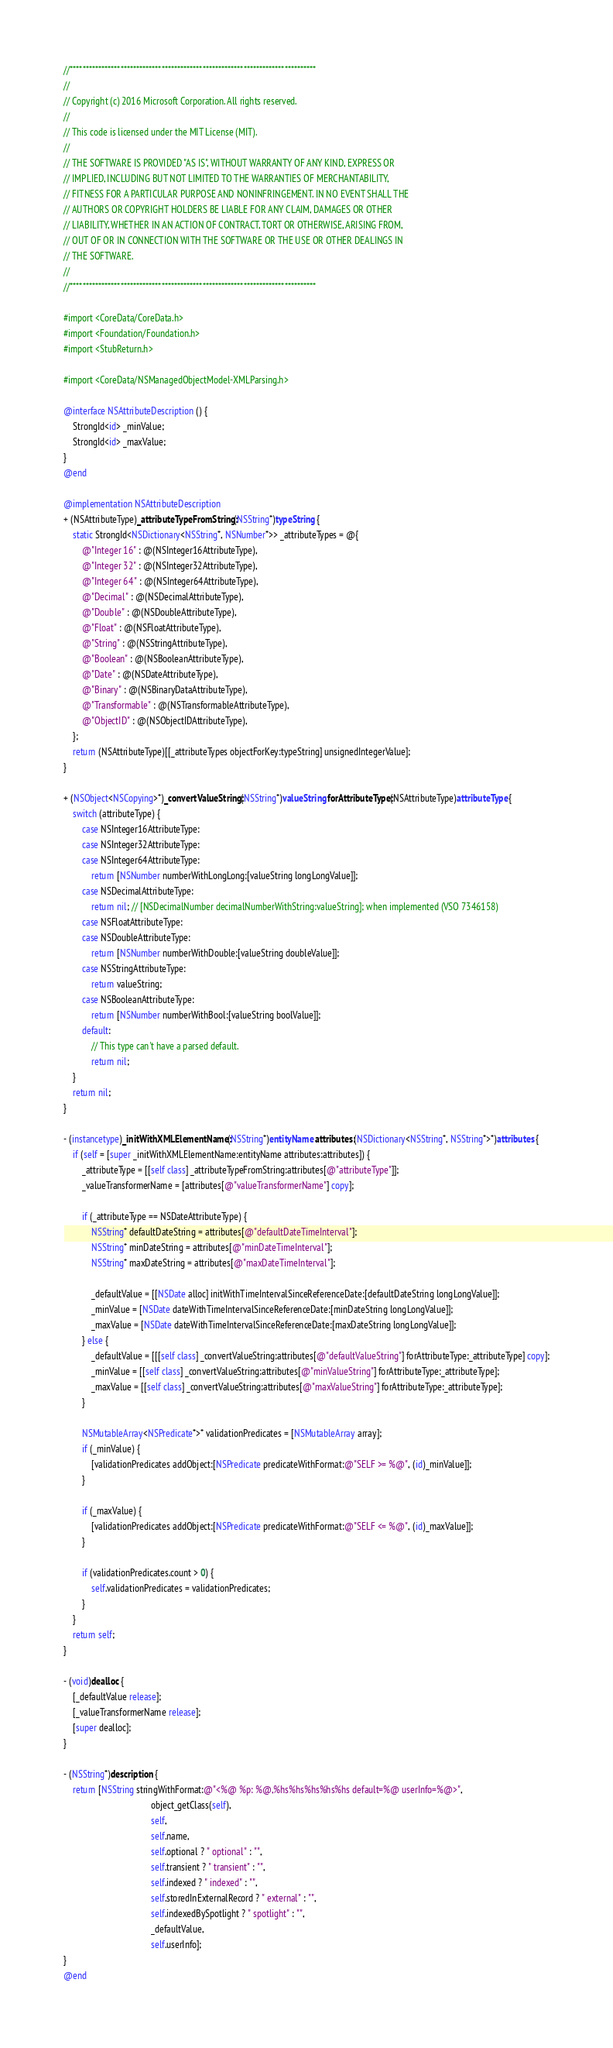Convert code to text. <code><loc_0><loc_0><loc_500><loc_500><_ObjectiveC_>//******************************************************************************
//
// Copyright (c) 2016 Microsoft Corporation. All rights reserved.
//
// This code is licensed under the MIT License (MIT).
//
// THE SOFTWARE IS PROVIDED "AS IS", WITHOUT WARRANTY OF ANY KIND, EXPRESS OR
// IMPLIED, INCLUDING BUT NOT LIMITED TO THE WARRANTIES OF MERCHANTABILITY,
// FITNESS FOR A PARTICULAR PURPOSE AND NONINFRINGEMENT. IN NO EVENT SHALL THE
// AUTHORS OR COPYRIGHT HOLDERS BE LIABLE FOR ANY CLAIM, DAMAGES OR OTHER
// LIABILITY, WHETHER IN AN ACTION OF CONTRACT, TORT OR OTHERWISE, ARISING FROM,
// OUT OF OR IN CONNECTION WITH THE SOFTWARE OR THE USE OR OTHER DEALINGS IN
// THE SOFTWARE.
//
//******************************************************************************

#import <CoreData/CoreData.h>
#import <Foundation/Foundation.h>
#import <StubReturn.h>

#import <CoreData/NSManagedObjectModel-XMLParsing.h>

@interface NSAttributeDescription () {
    StrongId<id> _minValue;
    StrongId<id> _maxValue;
}
@end

@implementation NSAttributeDescription
+ (NSAttributeType)_attributeTypeFromString:(NSString*)typeString {
    static StrongId<NSDictionary<NSString*, NSNumber*>> _attributeTypes = @{
        @"Integer 16" : @(NSInteger16AttributeType),
        @"Integer 32" : @(NSInteger32AttributeType),
        @"Integer 64" : @(NSInteger64AttributeType),
        @"Decimal" : @(NSDecimalAttributeType),
        @"Double" : @(NSDoubleAttributeType),
        @"Float" : @(NSFloatAttributeType),
        @"String" : @(NSStringAttributeType),
        @"Boolean" : @(NSBooleanAttributeType),
        @"Date" : @(NSDateAttributeType),
        @"Binary" : @(NSBinaryDataAttributeType),
        @"Transformable" : @(NSTransformableAttributeType),
        @"ObjectID" : @(NSObjectIDAttributeType),
    };
    return (NSAttributeType)[[_attributeTypes objectForKey:typeString] unsignedIntegerValue];
}

+ (NSObject<NSCopying>*)_convertValueString:(NSString*)valueString forAttributeType:(NSAttributeType)attributeType {
    switch (attributeType) {
        case NSInteger16AttributeType:
        case NSInteger32AttributeType:
        case NSInteger64AttributeType:
            return [NSNumber numberWithLongLong:[valueString longLongValue]];
        case NSDecimalAttributeType:
            return nil; // [NSDecimalNumber decimalNumberWithString:valueString]; when implemented (VSO 7346158)
        case NSFloatAttributeType:
        case NSDoubleAttributeType:
            return [NSNumber numberWithDouble:[valueString doubleValue]];
        case NSStringAttributeType:
            return valueString;
        case NSBooleanAttributeType:
            return [NSNumber numberWithBool:[valueString boolValue]];
        default:
            // This type can't have a parsed default.
            return nil;
    }
    return nil;
}

- (instancetype)_initWithXMLElementName:(NSString*)entityName attributes:(NSDictionary<NSString*, NSString*>*)attributes {
    if (self = [super _initWithXMLElementName:entityName attributes:attributes]) {
        _attributeType = [[self class] _attributeTypeFromString:attributes[@"attributeType"]];
        _valueTransformerName = [attributes[@"valueTransformerName"] copy];

        if (_attributeType == NSDateAttributeType) {
            NSString* defaultDateString = attributes[@"defaultDateTimeInterval"];
            NSString* minDateString = attributes[@"minDateTimeInterval"];
            NSString* maxDateString = attributes[@"maxDateTimeInterval"];

            _defaultValue = [[NSDate alloc] initWithTimeIntervalSinceReferenceDate:[defaultDateString longLongValue]];
            _minValue = [NSDate dateWithTimeIntervalSinceReferenceDate:[minDateString longLongValue]];
            _maxValue = [NSDate dateWithTimeIntervalSinceReferenceDate:[maxDateString longLongValue]];
        } else {
            _defaultValue = [[[self class] _convertValueString:attributes[@"defaultValueString"] forAttributeType:_attributeType] copy];
            _minValue = [[self class] _convertValueString:attributes[@"minValueString"] forAttributeType:_attributeType];
            _maxValue = [[self class] _convertValueString:attributes[@"maxValueString"] forAttributeType:_attributeType];
        }

        NSMutableArray<NSPredicate*>* validationPredicates = [NSMutableArray array];
        if (_minValue) {
            [validationPredicates addObject:[NSPredicate predicateWithFormat:@"SELF >= %@", (id)_minValue]];
        }

        if (_maxValue) {
            [validationPredicates addObject:[NSPredicate predicateWithFormat:@"SELF <= %@", (id)_maxValue]];
        }

        if (validationPredicates.count > 0) {
            self.validationPredicates = validationPredicates;
        }
    }
    return self;
}

- (void)dealloc {
    [_defaultValue release];
    [_valueTransformerName release];
    [super dealloc];
}

- (NSString*)description {
    return [NSString stringWithFormat:@"<%@ %p: %@,%hs%hs%hs%hs%hs default=%@ userInfo=%@>",
                                      object_getClass(self),
                                      self,
                                      self.name,
                                      self.optional ? " optional" : "",
                                      self.transient ? " transient" : "",
                                      self.indexed ? " indexed" : "",
                                      self.storedInExternalRecord ? " external" : "",
                                      self.indexedBySpotlight ? " spotlight" : "",
                                      _defaultValue,
                                      self.userInfo];
}
@end
</code> 